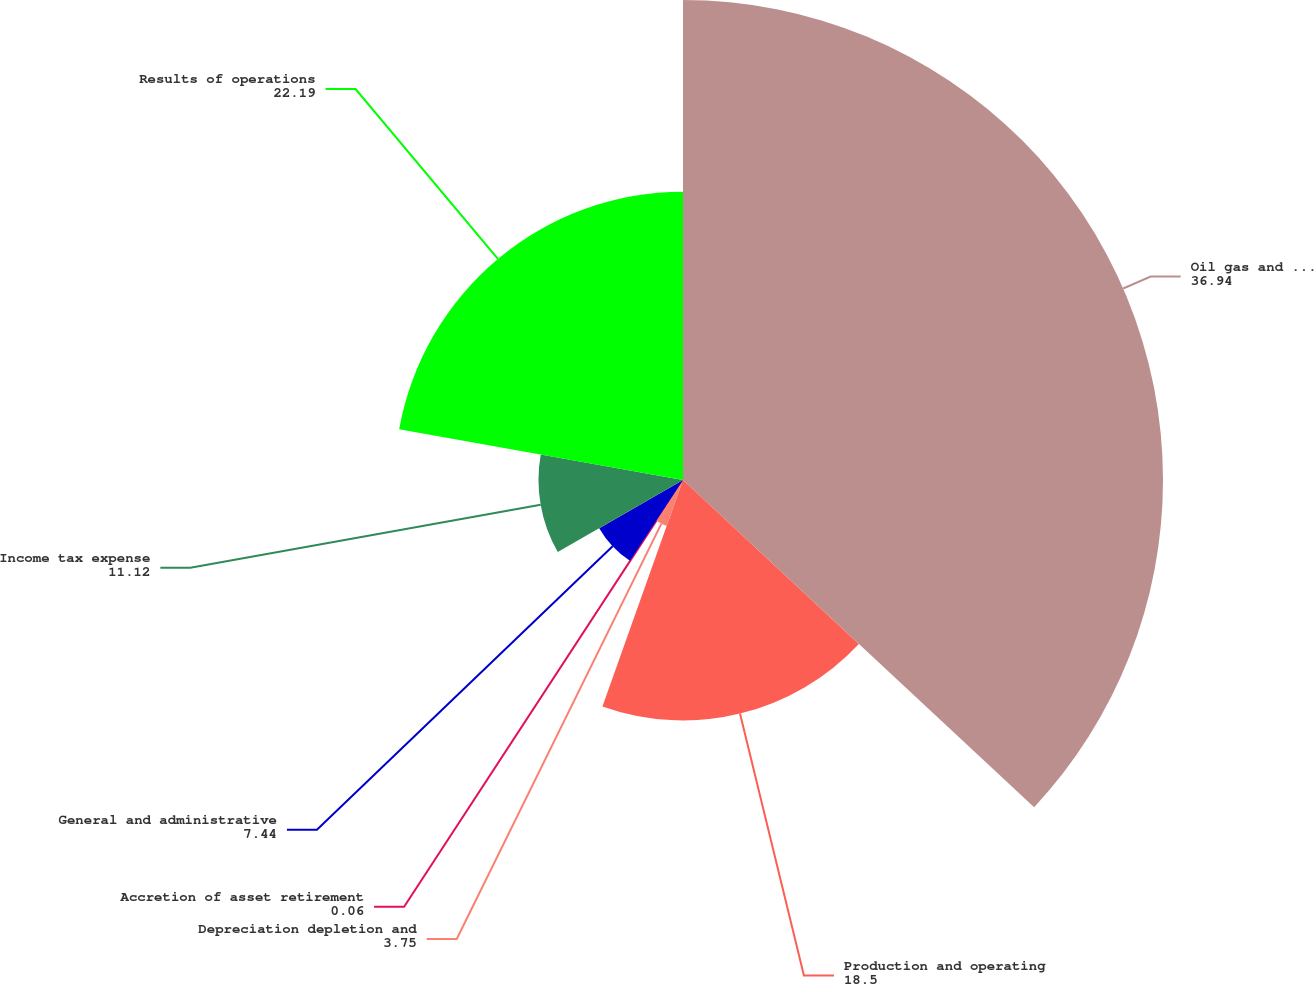Convert chart to OTSL. <chart><loc_0><loc_0><loc_500><loc_500><pie_chart><fcel>Oil gas and NGL sales<fcel>Production and operating<fcel>Depreciation depletion and<fcel>Accretion of asset retirement<fcel>General and administrative<fcel>Income tax expense<fcel>Results of operations<nl><fcel>36.94%<fcel>18.5%<fcel>3.75%<fcel>0.06%<fcel>7.44%<fcel>11.12%<fcel>22.19%<nl></chart> 